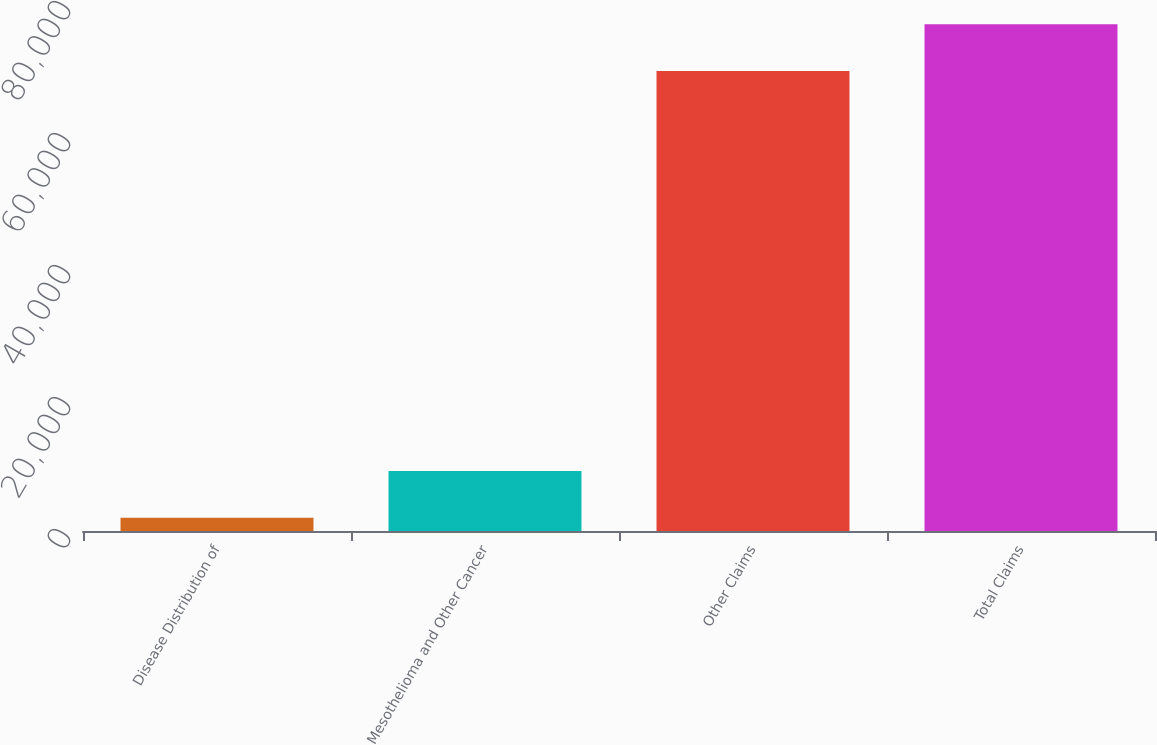Convert chart to OTSL. <chart><loc_0><loc_0><loc_500><loc_500><bar_chart><fcel>Disease Distribution of<fcel>Mesothelioma and Other Cancer<fcel>Other Claims<fcel>Total Claims<nl><fcel>2003<fcel>9100.3<fcel>69699<fcel>76796.3<nl></chart> 